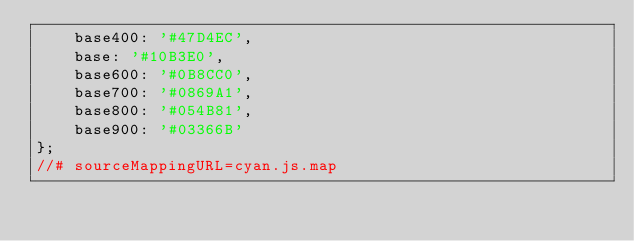<code> <loc_0><loc_0><loc_500><loc_500><_JavaScript_>    base400: '#47D4EC',
    base: '#10B3E0',
    base600: '#0B8CC0',
    base700: '#0869A1',
    base800: '#054B81',
    base900: '#03366B'
};
//# sourceMappingURL=cyan.js.map</code> 